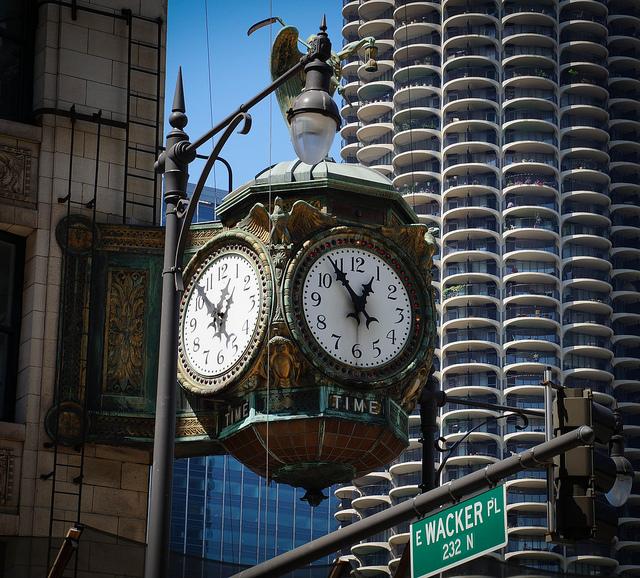Is this at town?
Keep it brief. Yes. How many clock faces?
Quick response, please. 2. What is the street number?
Write a very short answer. 232. What time does the clock show?
Keep it brief. 12:54. Is this a shopping center?
Quick response, please. No. What animals are decorating the clock?
Concise answer only. Eagles. 